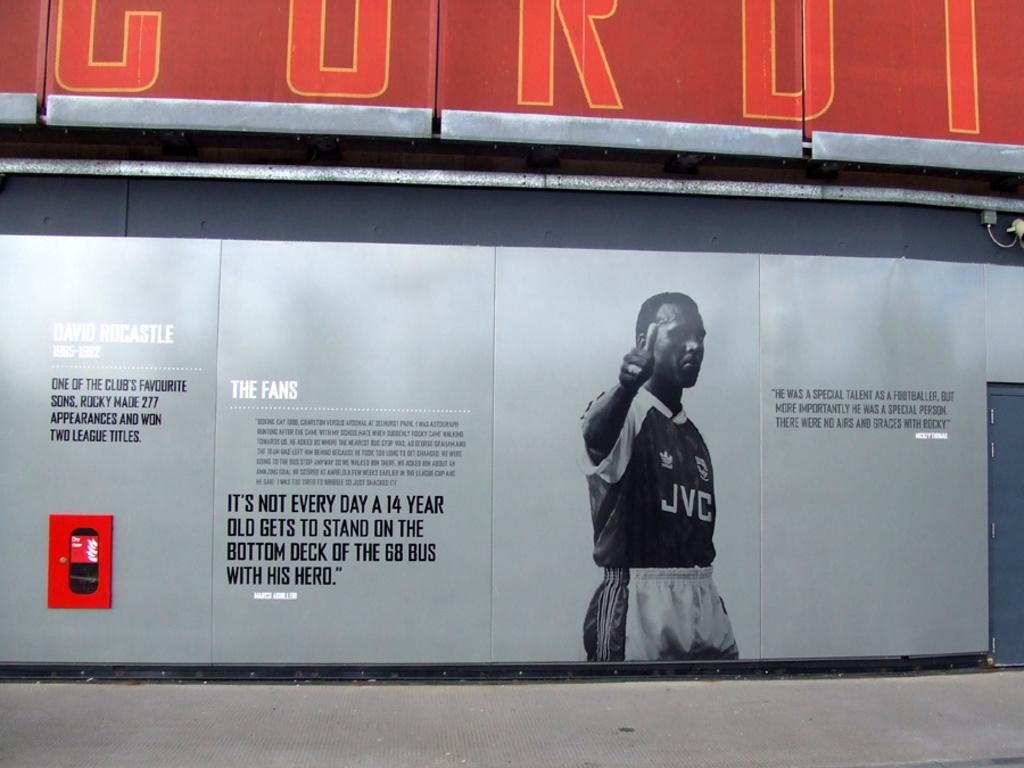<image>
Render a clear and concise summary of the photo. A billboard showing an athlete wearing a JVC emblem on his jersey. 